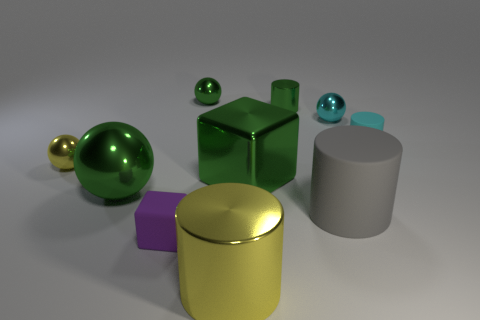Do the yellow thing that is behind the rubber block and the gray matte thing have the same size?
Offer a very short reply. No. Is the material of the tiny green ball the same as the tiny purple thing?
Your response must be concise. No. What is the cylinder that is both in front of the tiny cyan sphere and behind the big gray cylinder made of?
Keep it short and to the point. Rubber. There is a shiny sphere on the right side of the cube behind the green shiny ball that is in front of the tiny green sphere; what is its color?
Provide a short and direct response. Cyan. What number of objects are big shiny cubes that are behind the large green shiny sphere or big gray rubber objects?
Give a very brief answer. 2. What is the material of the cyan thing that is the same size as the cyan metal sphere?
Provide a short and direct response. Rubber. What is the small cube that is left of the cyan thing in front of the tiny shiny thing that is to the right of the big gray object made of?
Your response must be concise. Rubber. The shiny cube is what color?
Keep it short and to the point. Green. What number of big things are either green shiny cubes or cyan cylinders?
Keep it short and to the point. 1. Is the material of the tiny green thing to the left of the big shiny cube the same as the thing in front of the tiny purple matte thing?
Offer a very short reply. Yes. 